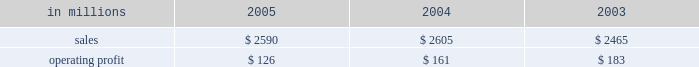Entering 2006 , industrial packaging earnings are expected to improve significantly in the first quarter compared with the fourth quarter 2005 .
Average price realizations should continue to benefit from price in- creases announced in late 2005 and early 2006 for linerboard and domestic boxes .
Containerboard sales volumes are expected to drop slightly in the 2006 first quarter due to fewer shipping days , but growth is antici- pated for u.s .
Converted products due to stronger de- mand .
Costs for wood , freight and energy are expected to remain stable during the 2006 first quarter , approach- ing fourth quarter 2005 levels .
The continued im- plementation of the new supply chain model at our mills during 2006 will bring additional efficiency improve- ments and cost savings .
On a global basis , the european container operating results are expected to improve as a result of targeted market growth and cost reduction ini- tiatives , and we will begin seeing further contributions from our recent moroccan box plant acquisition and from international paper distribution limited .
Consumer packaging demand and pricing for consumer packaging prod- ucts correlate closely with consumer spending and gen- eral economic activity .
In addition to prices and volumes , major factors affecting the profitability of con- sumer packaging are raw material and energy costs , manufacturing efficiency and product mix .
Consumer packaging 2019s 2005 net sales of $ 2.6 bil- lion were flat compared with 2004 and 5% ( 5 % ) higher com- pared with 2003 .
Operating profits in 2005 declined 22% ( 22 % ) from 2004 and 31% ( 31 % ) from 2003 as improved price realizations ( $ 46 million ) and favorable operations in the mills and converting operations ( $ 60 million ) could not overcome the impact of cost increases in energy , wood , polyethylene and other raw materials ( $ 120 million ) , lack-of-order downtime ( $ 13 million ) and other costs ( $ 8 million ) .
Consumer packaging in millions 2005 2004 2003 .
Bleached board net sales of $ 864 million in 2005 were up from $ 842 million in 2004 and $ 751 million in 2003 .
The effects in 2005 of improved average price realizations and mill operating improvements were not enough to offset increased energy , wood , polyethylene and other raw material costs , a slight decrease in volume and increased lack-of-order downtime .
Bleached board mills took 100000 tons of downtime in 2005 , including 65000 tons of lack-of-order downtime , compared with 40000 tons of downtime in 2004 , none of which was market related .
During 2005 , restructuring and manufacturing improvement plans were implemented to reduce costs and improve market alignment .
Foodservice net sales were $ 437 million in 2005 compared with $ 480 million in 2004 and $ 460 million in 2003 .
Average sales prices in 2005 were up 3% ( 3 % ) ; how- ever , domestic cup and lid sales volumes were 5% ( 5 % ) lower than in 2004 as a result of a rationalization of our cus- tomer base early in 2005 .
Operating profits in 2005 in- creased 147% ( 147 % ) compared with 2004 , largely due to the settlement of a lawsuit and a favorable adjustment on the sale of the jackson , tennessee bag plant .
Excluding unusual items , operating profits were flat as improved price realizations offset increased costs for bleached board and resin .
Shorewood net sales of $ 691 million in 2005 were essentially flat with net sales in 2004 of $ 687 million , but were up compared with $ 665 million in 2003 .
Operating profits in 2005 were 17% ( 17 % ) above 2004 levels and about equal to 2003 levels .
Improved margins resulting from a rationalization of the customer mix and the effects of improved manufacturing operations , including the successful start up of our south korean tobacco operations , more than offset cost increases for board and paper and the impact of unfavorable foreign exchange rates in canada .
Beverage packaging net sales were $ 597 million in 2005 , $ 595 million in 2004 and $ 589 million in 2003 .
Average sale price realizations increased 2% ( 2 % ) compared with 2004 , principally the result of the pass-through of higher raw material costs , although the implementation of price increases continues to be impacted by com- petitive pressures .
Operating profits were down 14% ( 14 % ) compared with 2004 and 19% ( 19 % ) compared with 2003 , due principally to increases in board and resin costs .
In 2006 , the bleached board market is expected to remain strong , with sales volumes increasing in the first quarter compared with the fourth quarter of 2005 for both folding carton and cup products .
Improved price realizations are also expected for bleached board and in our foodservice and beverage packaging businesses , al- though continued high costs for energy , wood and resin will continue to negatively impact earnings .
Shorewood should continue to benefit from strong asian operations and from targeted sales volume growth in 2006 .
Capital improvements and operational excellence initiatives undertaken in 2005 should benefit operating results in 2006 for all businesses .
Distribution our distribution business , principally represented by our xpedx business , markets a diverse array of products and supply chain services to customers in many business segments .
Customer demand is generally sensitive to changes in general economic conditions , although the .
Was percentage of consumer packaging sales was due to foodservice net sales in 2005? 
Computations: (437 / 2590)
Answer: 0.16873. 